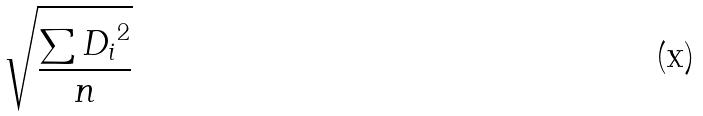Convert formula to latex. <formula><loc_0><loc_0><loc_500><loc_500>\sqrt { \frac { \sum { D _ { i } } ^ { 2 } } { n } }</formula> 